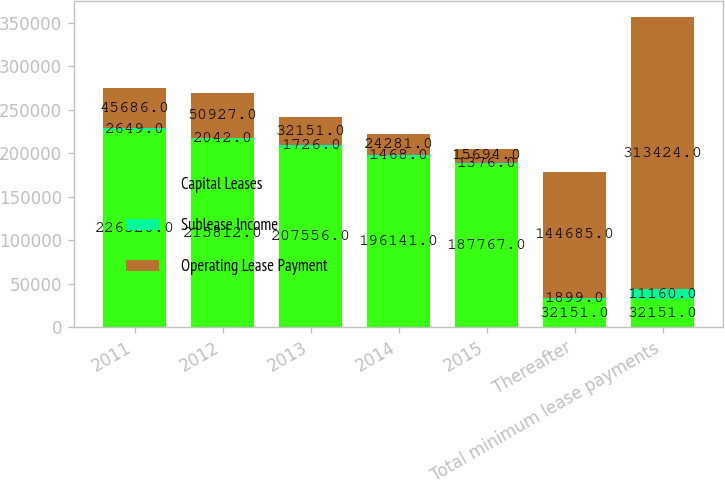<chart> <loc_0><loc_0><loc_500><loc_500><stacked_bar_chart><ecel><fcel>2011<fcel>2012<fcel>2013<fcel>2014<fcel>2015<fcel>Thereafter<fcel>Total minimum lease payments<nl><fcel>Capital Leases<fcel>226320<fcel>215812<fcel>207556<fcel>196141<fcel>187767<fcel>32151<fcel>32151<nl><fcel>Sublease Income<fcel>2649<fcel>2042<fcel>1726<fcel>1468<fcel>1376<fcel>1899<fcel>11160<nl><fcel>Operating Lease Payment<fcel>45686<fcel>50927<fcel>32151<fcel>24281<fcel>15694<fcel>144685<fcel>313424<nl></chart> 